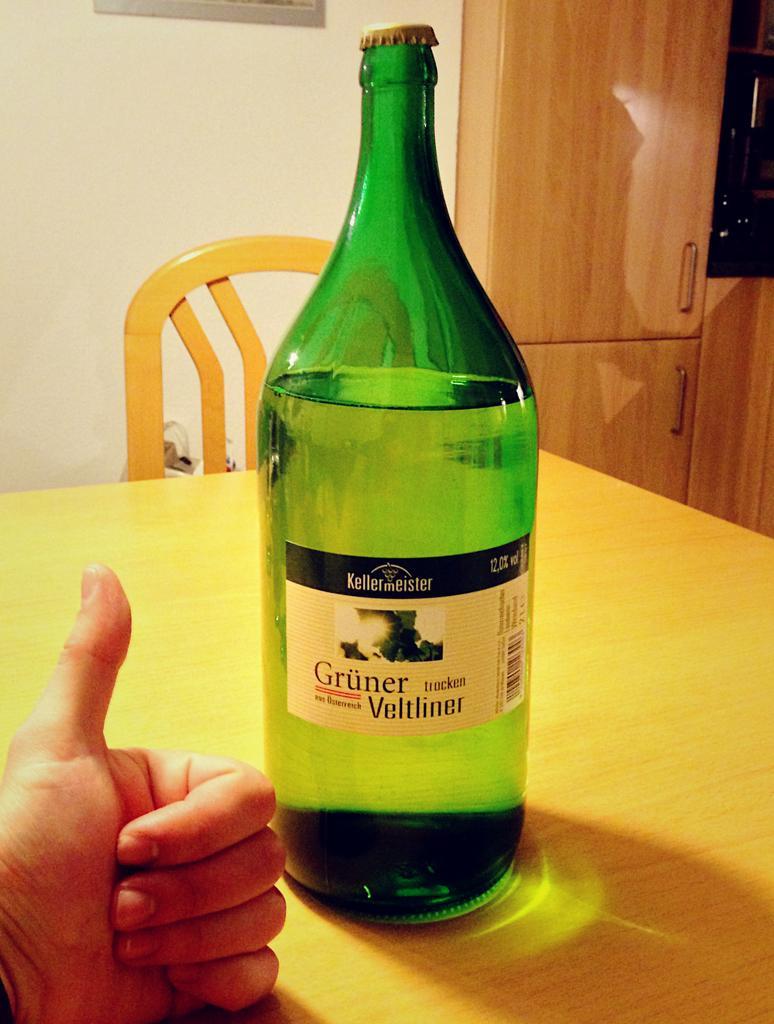In one or two sentences, can you explain what this image depicts? In this image there is a bottle on the table. There is a label on the bottle with text on it. Behind the table there is a chair. To the below left corner of the image there is a hand showing thumbs up. In the background there is wall and a wooden cupboard. 